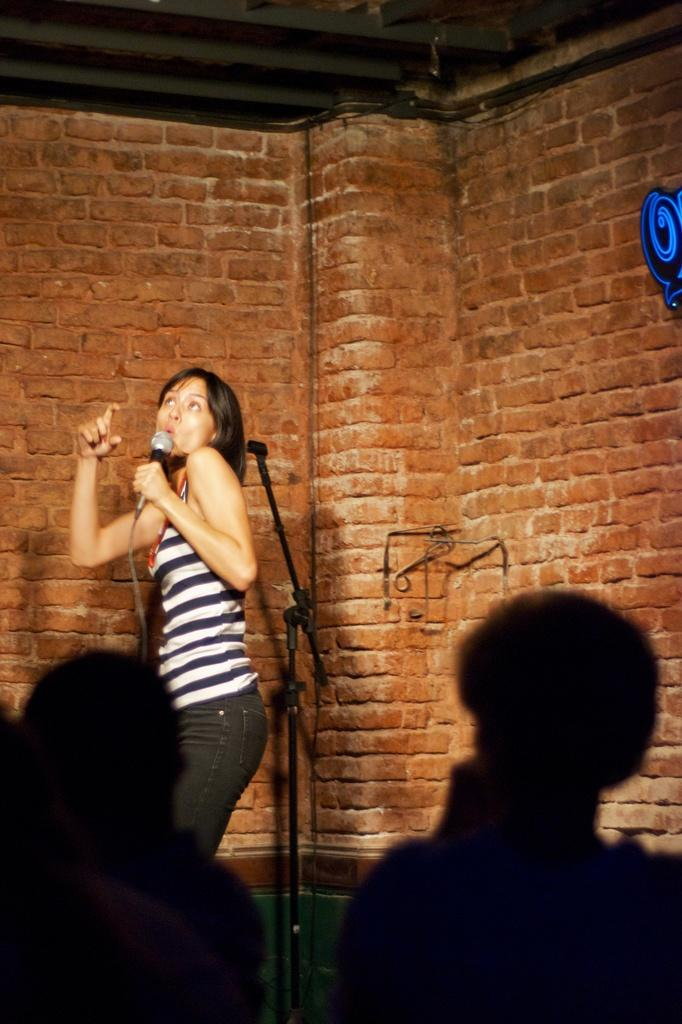Who is the main subject in the image? There is a woman in the image. What is the woman holding in her hand? The woman is holding a microphone in her hand. What can be seen in the background of the image? There is a wall in the background of the image. What type of instrument is the woman playing in the image? The woman is not playing an instrument in the image; she is holding a microphone. Is there any milk visible in the image? No, there is no milk present in the image. 